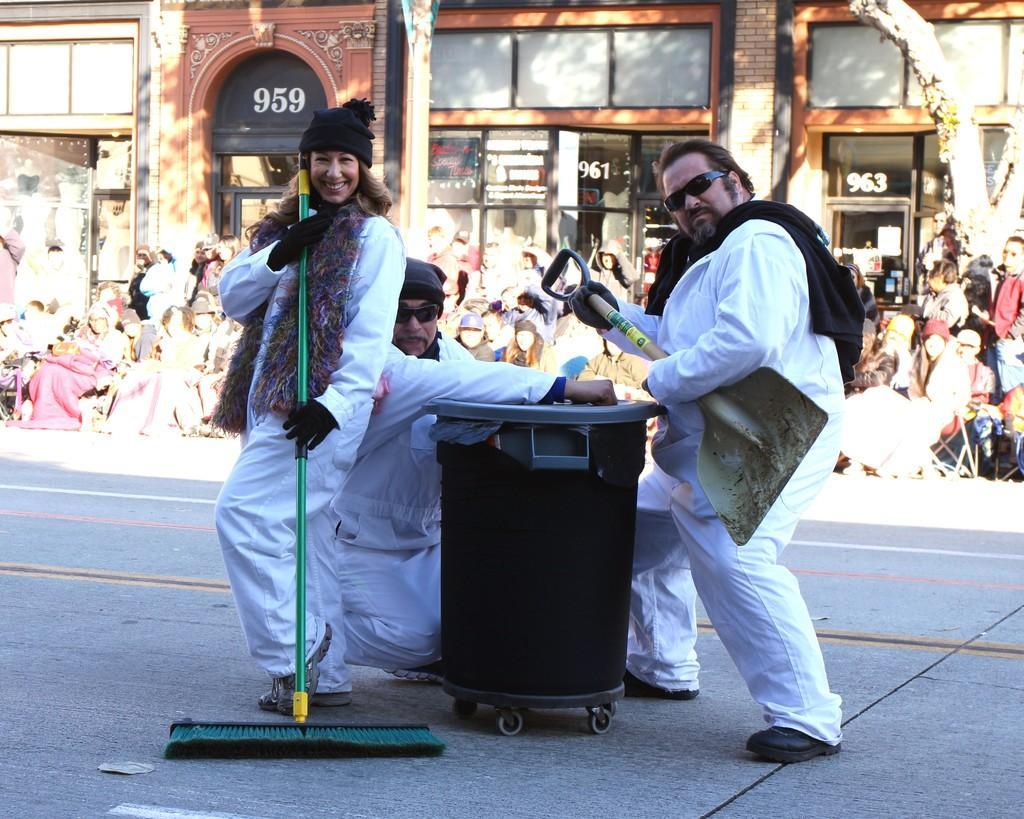Please provide a concise description of this image. This picture is clicked outside the city. In the middle of the picture, we see three people wearing white shirts are performing on the road. Out of them, two are men and the one is a woman and she is smiling. Behind them, we see people sitting on the chairs. Behind them, we see a building in brown color. We even see doors and windows. On the right side, we see a tree. It is a sunny day. 